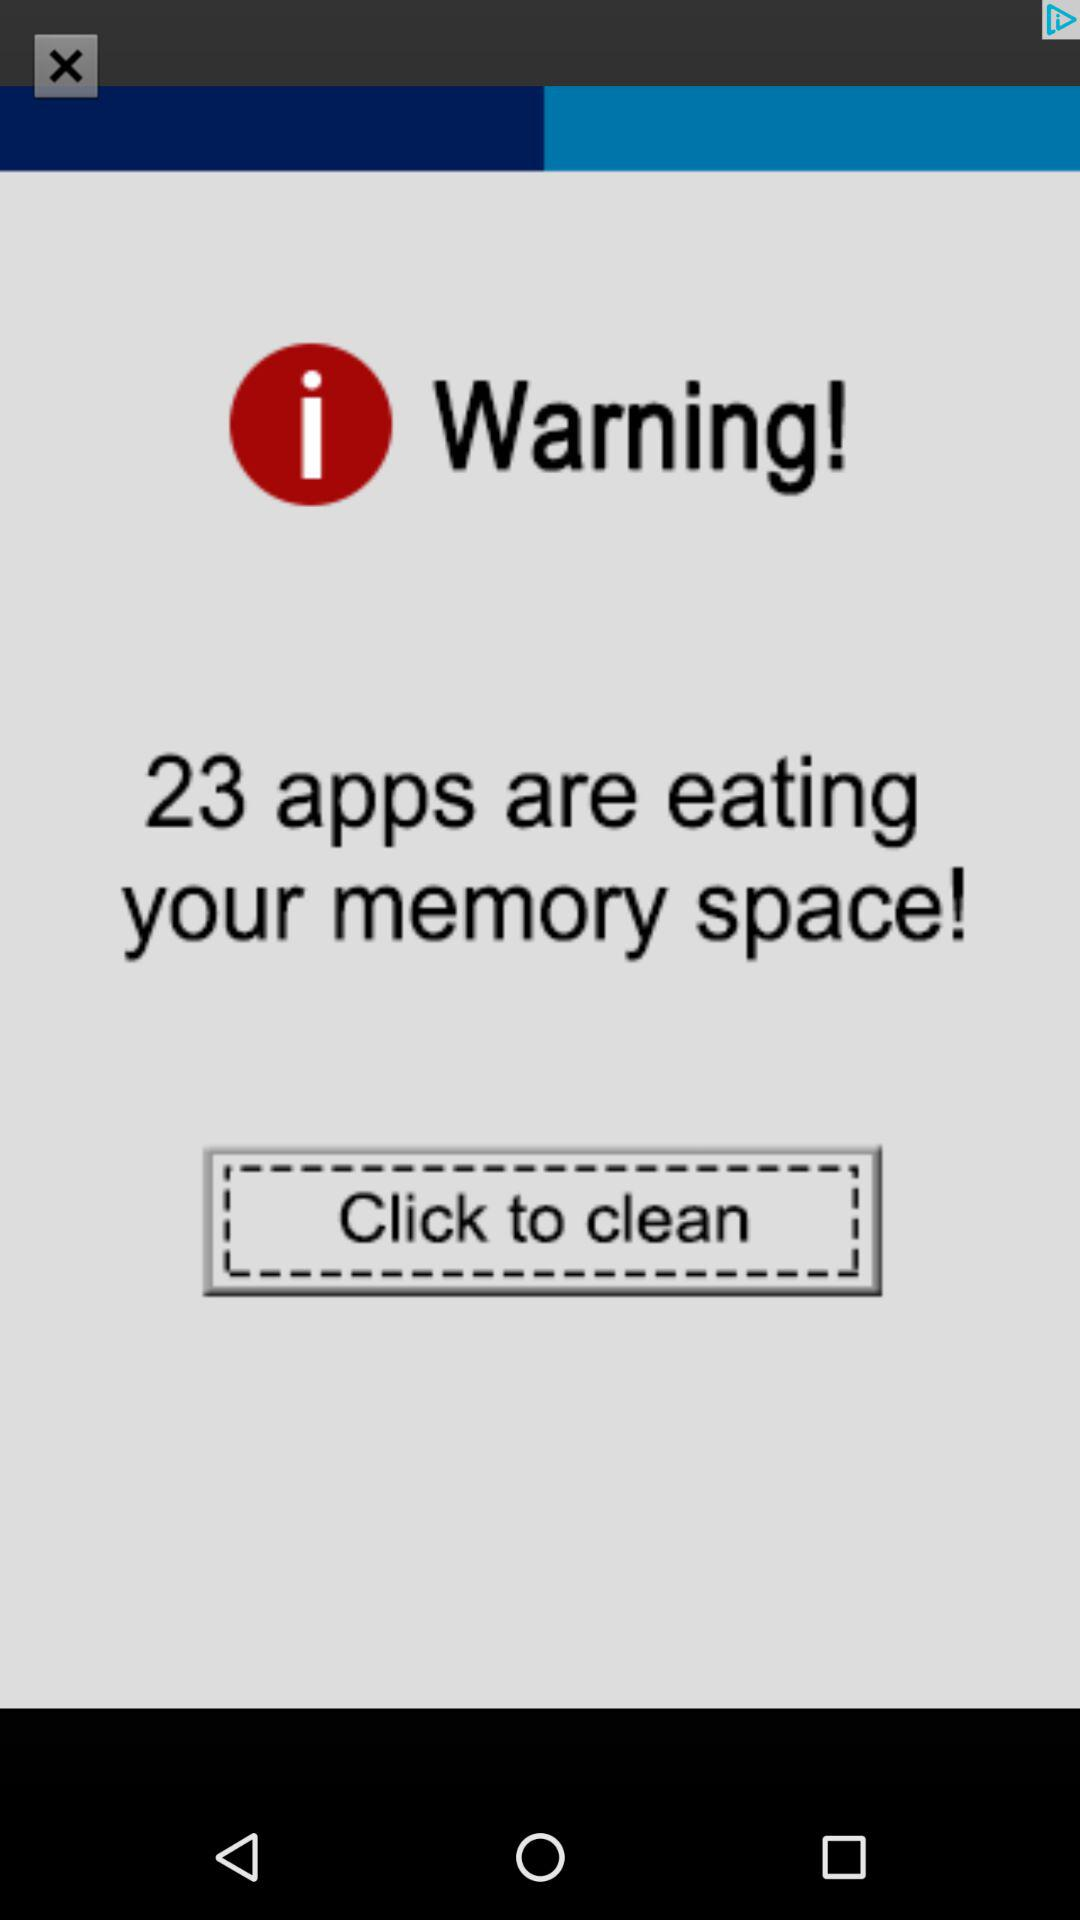How many apps are taking up the most memory?
Answer the question using a single word or phrase. 23 